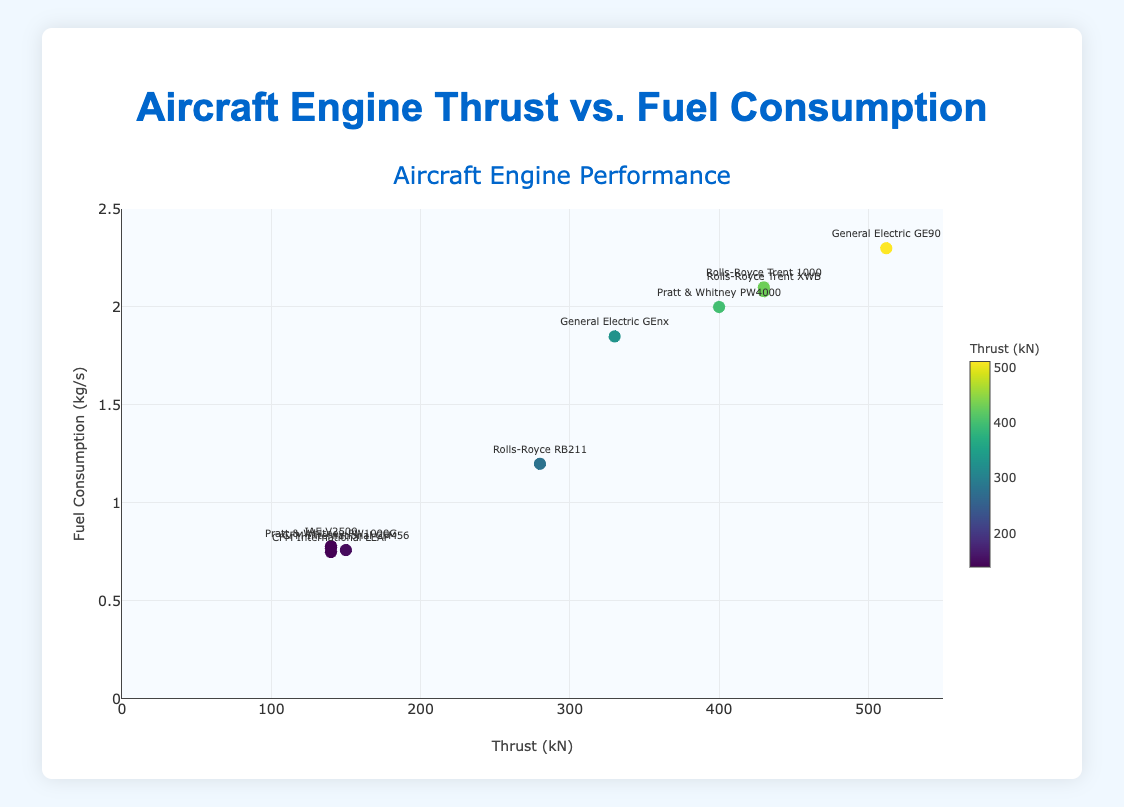What is the title of the scatter plot? The title of the scatter plot is found at the top of the figure, which provides a high-level description of the data being visualized.
Answer: Aircraft Engine Thrust vs. Fuel Consumption How many aircraft engine models are represented in the scatter plot? Count the number of markers on the scatter plot, each representing an aircraft engine model. There should be a label next to each marker with the engine model name.
Answer: 10 What is the thrust of the engine model with the highest fuel consumption rate? Locate the data point that is highest on the y-axis (fuel consumption rate) and check the corresponding x-axis value (thrust).
Answer: 512 kN Which aircraft engine model has the lowest fuel consumption rate? Find the data point that is lowest on the y-axis (fuel consumption rate) and read the label next to it.
Answer: CFM International LEAP What is the range of the fuel consumption axis? Observe the labels along the y-axis to determine the minimum and maximum values shown.
Answer: 0 to 2.5 kg/s How does the fuel consumption rate of the Rolls-Royce Trent 1000 compare to that of the Rolls-Royce Trent XWB? Find the data points for both models and compare their y-values (fuel consumption rates). The y-value of Rolls-Royce Trent 1000 is slightly higher.
Answer: The Trent 1000 has a higher fuel consumption rate than the Trent XWB What is the average thrust of engines with a fuel consumption rate below 1 kg/s? Identify the engines with y-values (fuel consumption rate) below 1 kg/s, then calculate the average of their x-values (thrust). These engines are CFM56, V2500, PW1000G, and LEAP. Their thrust values are 150, 140, 140, and 140 respectively. The sum is 570 and the average is 570/4.
Answer: 142.5 kN Does there appear to be a general trend between thrust and fuel consumption? Observe the overall distribution of data points and determine if there is an apparent relationship between the x-values (thrust) and y-values (fuel consumption). Generally, as thrust increases, fuel consumption seems to increase as well.
Answer: Yes, there is a positive correlation Which engine model has exactly 330 kN of thrust, and what is its fuel consumption rate? Locate the data point where the x-value (thrust) is 330 kN and read its y-value (fuel consumption rate) and the engine model name next to it.
Answer: General Electric GEnx, 1.85 kg/s 